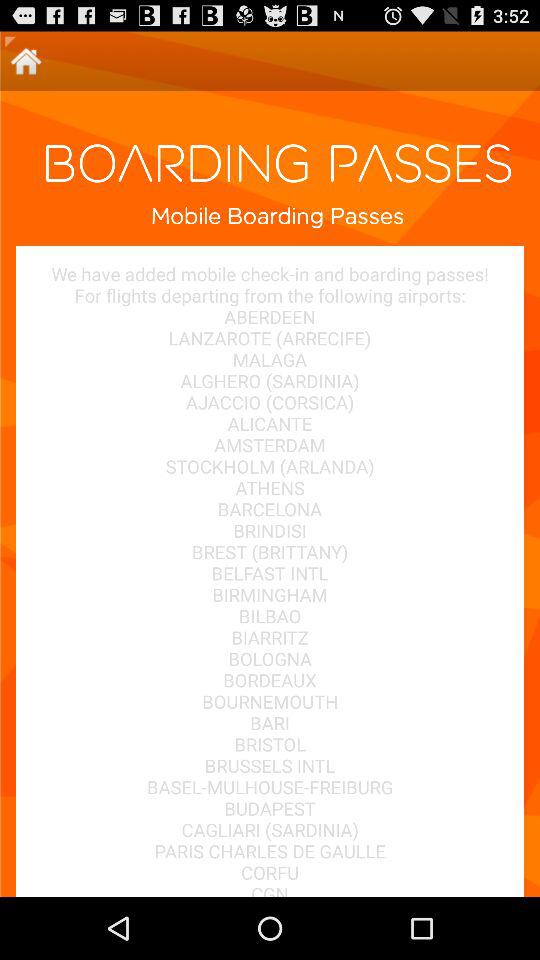What is the application name?
When the provided information is insufficient, respond with <no answer>. <no answer> 